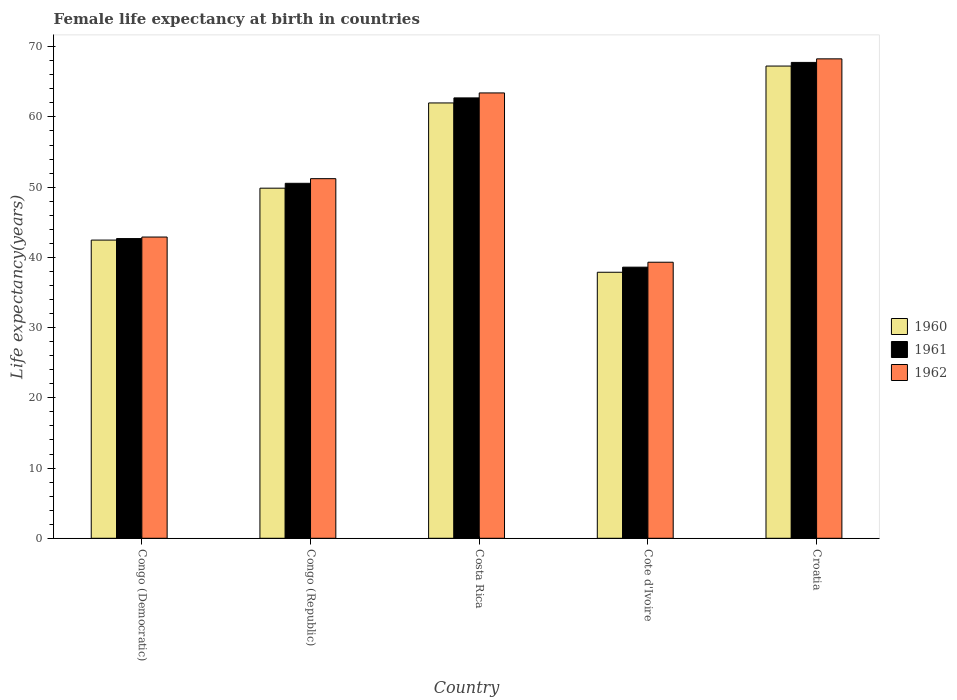Are the number of bars per tick equal to the number of legend labels?
Provide a short and direct response. Yes. Are the number of bars on each tick of the X-axis equal?
Ensure brevity in your answer.  Yes. How many bars are there on the 5th tick from the right?
Offer a very short reply. 3. What is the label of the 4th group of bars from the left?
Provide a succinct answer. Cote d'Ivoire. In how many cases, is the number of bars for a given country not equal to the number of legend labels?
Offer a terse response. 0. What is the female life expectancy at birth in 1962 in Congo (Democratic)?
Give a very brief answer. 42.9. Across all countries, what is the maximum female life expectancy at birth in 1961?
Provide a short and direct response. 67.77. Across all countries, what is the minimum female life expectancy at birth in 1961?
Make the answer very short. 38.61. In which country was the female life expectancy at birth in 1961 maximum?
Offer a terse response. Croatia. In which country was the female life expectancy at birth in 1960 minimum?
Offer a terse response. Cote d'Ivoire. What is the total female life expectancy at birth in 1960 in the graph?
Make the answer very short. 259.45. What is the difference between the female life expectancy at birth in 1960 in Congo (Democratic) and that in Cote d'Ivoire?
Provide a short and direct response. 4.58. What is the difference between the female life expectancy at birth in 1962 in Congo (Democratic) and the female life expectancy at birth in 1960 in Costa Rica?
Offer a very short reply. -19.1. What is the average female life expectancy at birth in 1960 per country?
Make the answer very short. 51.89. What is the difference between the female life expectancy at birth of/in 1960 and female life expectancy at birth of/in 1961 in Congo (Republic)?
Keep it short and to the point. -0.69. What is the ratio of the female life expectancy at birth in 1961 in Congo (Democratic) to that in Croatia?
Keep it short and to the point. 0.63. Is the difference between the female life expectancy at birth in 1960 in Cote d'Ivoire and Croatia greater than the difference between the female life expectancy at birth in 1961 in Cote d'Ivoire and Croatia?
Give a very brief answer. No. What is the difference between the highest and the second highest female life expectancy at birth in 1961?
Your answer should be compact. -17.22. What is the difference between the highest and the lowest female life expectancy at birth in 1962?
Keep it short and to the point. 28.96. What is the difference between two consecutive major ticks on the Y-axis?
Make the answer very short. 10. Are the values on the major ticks of Y-axis written in scientific E-notation?
Give a very brief answer. No. What is the title of the graph?
Your answer should be very brief. Female life expectancy at birth in countries. Does "2011" appear as one of the legend labels in the graph?
Provide a succinct answer. No. What is the label or title of the Y-axis?
Your answer should be compact. Life expectancy(years). What is the Life expectancy(years) of 1960 in Congo (Democratic)?
Offer a very short reply. 42.47. What is the Life expectancy(years) of 1961 in Congo (Democratic)?
Provide a short and direct response. 42.68. What is the Life expectancy(years) in 1962 in Congo (Democratic)?
Provide a short and direct response. 42.9. What is the Life expectancy(years) of 1960 in Congo (Republic)?
Make the answer very short. 49.86. What is the Life expectancy(years) in 1961 in Congo (Republic)?
Give a very brief answer. 50.55. What is the Life expectancy(years) of 1962 in Congo (Republic)?
Offer a terse response. 51.21. What is the Life expectancy(years) of 1960 in Costa Rica?
Provide a succinct answer. 62. What is the Life expectancy(years) of 1961 in Costa Rica?
Your answer should be compact. 62.71. What is the Life expectancy(years) of 1962 in Costa Rica?
Provide a succinct answer. 63.42. What is the Life expectancy(years) in 1960 in Cote d'Ivoire?
Your answer should be compact. 37.88. What is the Life expectancy(years) in 1961 in Cote d'Ivoire?
Keep it short and to the point. 38.61. What is the Life expectancy(years) in 1962 in Cote d'Ivoire?
Keep it short and to the point. 39.31. What is the Life expectancy(years) in 1960 in Croatia?
Make the answer very short. 67.25. What is the Life expectancy(years) of 1961 in Croatia?
Your answer should be compact. 67.77. What is the Life expectancy(years) of 1962 in Croatia?
Keep it short and to the point. 68.28. Across all countries, what is the maximum Life expectancy(years) in 1960?
Offer a very short reply. 67.25. Across all countries, what is the maximum Life expectancy(years) in 1961?
Your response must be concise. 67.77. Across all countries, what is the maximum Life expectancy(years) of 1962?
Offer a terse response. 68.28. Across all countries, what is the minimum Life expectancy(years) in 1960?
Offer a very short reply. 37.88. Across all countries, what is the minimum Life expectancy(years) of 1961?
Ensure brevity in your answer.  38.61. Across all countries, what is the minimum Life expectancy(years) of 1962?
Provide a short and direct response. 39.31. What is the total Life expectancy(years) in 1960 in the graph?
Offer a terse response. 259.45. What is the total Life expectancy(years) of 1961 in the graph?
Make the answer very short. 262.32. What is the total Life expectancy(years) in 1962 in the graph?
Your response must be concise. 265.12. What is the difference between the Life expectancy(years) of 1960 in Congo (Democratic) and that in Congo (Republic)?
Offer a very short reply. -7.39. What is the difference between the Life expectancy(years) of 1961 in Congo (Democratic) and that in Congo (Republic)?
Make the answer very short. -7.87. What is the difference between the Life expectancy(years) in 1962 in Congo (Democratic) and that in Congo (Republic)?
Your response must be concise. -8.31. What is the difference between the Life expectancy(years) in 1960 in Congo (Democratic) and that in Costa Rica?
Ensure brevity in your answer.  -19.53. What is the difference between the Life expectancy(years) of 1961 in Congo (Democratic) and that in Costa Rica?
Offer a very short reply. -20.03. What is the difference between the Life expectancy(years) of 1962 in Congo (Democratic) and that in Costa Rica?
Offer a very short reply. -20.52. What is the difference between the Life expectancy(years) in 1960 in Congo (Democratic) and that in Cote d'Ivoire?
Your answer should be compact. 4.58. What is the difference between the Life expectancy(years) of 1961 in Congo (Democratic) and that in Cote d'Ivoire?
Keep it short and to the point. 4.07. What is the difference between the Life expectancy(years) of 1962 in Congo (Democratic) and that in Cote d'Ivoire?
Give a very brief answer. 3.59. What is the difference between the Life expectancy(years) in 1960 in Congo (Democratic) and that in Croatia?
Offer a very short reply. -24.78. What is the difference between the Life expectancy(years) of 1961 in Congo (Democratic) and that in Croatia?
Ensure brevity in your answer.  -25.09. What is the difference between the Life expectancy(years) in 1962 in Congo (Democratic) and that in Croatia?
Make the answer very short. -25.38. What is the difference between the Life expectancy(years) of 1960 in Congo (Republic) and that in Costa Rica?
Offer a very short reply. -12.14. What is the difference between the Life expectancy(years) of 1961 in Congo (Republic) and that in Costa Rica?
Keep it short and to the point. -12.16. What is the difference between the Life expectancy(years) in 1962 in Congo (Republic) and that in Costa Rica?
Make the answer very short. -12.21. What is the difference between the Life expectancy(years) in 1960 in Congo (Republic) and that in Cote d'Ivoire?
Provide a short and direct response. 11.97. What is the difference between the Life expectancy(years) of 1961 in Congo (Republic) and that in Cote d'Ivoire?
Keep it short and to the point. 11.94. What is the difference between the Life expectancy(years) of 1962 in Congo (Republic) and that in Cote d'Ivoire?
Offer a very short reply. 11.9. What is the difference between the Life expectancy(years) of 1960 in Congo (Republic) and that in Croatia?
Offer a very short reply. -17.39. What is the difference between the Life expectancy(years) of 1961 in Congo (Republic) and that in Croatia?
Your response must be concise. -17.21. What is the difference between the Life expectancy(years) in 1962 in Congo (Republic) and that in Croatia?
Your answer should be compact. -17.06. What is the difference between the Life expectancy(years) of 1960 in Costa Rica and that in Cote d'Ivoire?
Give a very brief answer. 24.11. What is the difference between the Life expectancy(years) in 1961 in Costa Rica and that in Cote d'Ivoire?
Provide a short and direct response. 24.1. What is the difference between the Life expectancy(years) in 1962 in Costa Rica and that in Cote d'Ivoire?
Give a very brief answer. 24.11. What is the difference between the Life expectancy(years) of 1960 in Costa Rica and that in Croatia?
Provide a short and direct response. -5.25. What is the difference between the Life expectancy(years) of 1961 in Costa Rica and that in Croatia?
Give a very brief answer. -5.05. What is the difference between the Life expectancy(years) in 1962 in Costa Rica and that in Croatia?
Your answer should be compact. -4.85. What is the difference between the Life expectancy(years) in 1960 in Cote d'Ivoire and that in Croatia?
Provide a succinct answer. -29.36. What is the difference between the Life expectancy(years) in 1961 in Cote d'Ivoire and that in Croatia?
Your answer should be compact. -29.16. What is the difference between the Life expectancy(years) of 1962 in Cote d'Ivoire and that in Croatia?
Offer a very short reply. -28.96. What is the difference between the Life expectancy(years) in 1960 in Congo (Democratic) and the Life expectancy(years) in 1961 in Congo (Republic)?
Your answer should be compact. -8.09. What is the difference between the Life expectancy(years) of 1960 in Congo (Democratic) and the Life expectancy(years) of 1962 in Congo (Republic)?
Your answer should be compact. -8.75. What is the difference between the Life expectancy(years) of 1961 in Congo (Democratic) and the Life expectancy(years) of 1962 in Congo (Republic)?
Provide a short and direct response. -8.53. What is the difference between the Life expectancy(years) in 1960 in Congo (Democratic) and the Life expectancy(years) in 1961 in Costa Rica?
Offer a very short reply. -20.25. What is the difference between the Life expectancy(years) of 1960 in Congo (Democratic) and the Life expectancy(years) of 1962 in Costa Rica?
Your answer should be compact. -20.96. What is the difference between the Life expectancy(years) of 1961 in Congo (Democratic) and the Life expectancy(years) of 1962 in Costa Rica?
Offer a terse response. -20.74. What is the difference between the Life expectancy(years) in 1960 in Congo (Democratic) and the Life expectancy(years) in 1961 in Cote d'Ivoire?
Your answer should be compact. 3.85. What is the difference between the Life expectancy(years) of 1960 in Congo (Democratic) and the Life expectancy(years) of 1962 in Cote d'Ivoire?
Keep it short and to the point. 3.15. What is the difference between the Life expectancy(years) in 1961 in Congo (Democratic) and the Life expectancy(years) in 1962 in Cote d'Ivoire?
Offer a terse response. 3.37. What is the difference between the Life expectancy(years) in 1960 in Congo (Democratic) and the Life expectancy(years) in 1961 in Croatia?
Make the answer very short. -25.3. What is the difference between the Life expectancy(years) in 1960 in Congo (Democratic) and the Life expectancy(years) in 1962 in Croatia?
Keep it short and to the point. -25.81. What is the difference between the Life expectancy(years) in 1961 in Congo (Democratic) and the Life expectancy(years) in 1962 in Croatia?
Provide a succinct answer. -25.59. What is the difference between the Life expectancy(years) in 1960 in Congo (Republic) and the Life expectancy(years) in 1961 in Costa Rica?
Your answer should be very brief. -12.86. What is the difference between the Life expectancy(years) of 1960 in Congo (Republic) and the Life expectancy(years) of 1962 in Costa Rica?
Your answer should be compact. -13.56. What is the difference between the Life expectancy(years) in 1961 in Congo (Republic) and the Life expectancy(years) in 1962 in Costa Rica?
Make the answer very short. -12.87. What is the difference between the Life expectancy(years) of 1960 in Congo (Republic) and the Life expectancy(years) of 1961 in Cote d'Ivoire?
Provide a short and direct response. 11.25. What is the difference between the Life expectancy(years) of 1960 in Congo (Republic) and the Life expectancy(years) of 1962 in Cote d'Ivoire?
Make the answer very short. 10.54. What is the difference between the Life expectancy(years) in 1961 in Congo (Republic) and the Life expectancy(years) in 1962 in Cote d'Ivoire?
Your response must be concise. 11.24. What is the difference between the Life expectancy(years) in 1960 in Congo (Republic) and the Life expectancy(years) in 1961 in Croatia?
Give a very brief answer. -17.91. What is the difference between the Life expectancy(years) in 1960 in Congo (Republic) and the Life expectancy(years) in 1962 in Croatia?
Provide a succinct answer. -18.42. What is the difference between the Life expectancy(years) of 1961 in Congo (Republic) and the Life expectancy(years) of 1962 in Croatia?
Provide a succinct answer. -17.72. What is the difference between the Life expectancy(years) in 1960 in Costa Rica and the Life expectancy(years) in 1961 in Cote d'Ivoire?
Keep it short and to the point. 23.39. What is the difference between the Life expectancy(years) in 1960 in Costa Rica and the Life expectancy(years) in 1962 in Cote d'Ivoire?
Your response must be concise. 22.68. What is the difference between the Life expectancy(years) in 1961 in Costa Rica and the Life expectancy(years) in 1962 in Cote d'Ivoire?
Your answer should be very brief. 23.4. What is the difference between the Life expectancy(years) of 1960 in Costa Rica and the Life expectancy(years) of 1961 in Croatia?
Keep it short and to the point. -5.77. What is the difference between the Life expectancy(years) in 1960 in Costa Rica and the Life expectancy(years) in 1962 in Croatia?
Keep it short and to the point. -6.28. What is the difference between the Life expectancy(years) of 1961 in Costa Rica and the Life expectancy(years) of 1962 in Croatia?
Provide a short and direct response. -5.56. What is the difference between the Life expectancy(years) of 1960 in Cote d'Ivoire and the Life expectancy(years) of 1961 in Croatia?
Ensure brevity in your answer.  -29.88. What is the difference between the Life expectancy(years) in 1960 in Cote d'Ivoire and the Life expectancy(years) in 1962 in Croatia?
Your answer should be compact. -30.39. What is the difference between the Life expectancy(years) in 1961 in Cote d'Ivoire and the Life expectancy(years) in 1962 in Croatia?
Your response must be concise. -29.66. What is the average Life expectancy(years) of 1960 per country?
Provide a succinct answer. 51.89. What is the average Life expectancy(years) in 1961 per country?
Give a very brief answer. 52.46. What is the average Life expectancy(years) of 1962 per country?
Offer a very short reply. 53.02. What is the difference between the Life expectancy(years) of 1960 and Life expectancy(years) of 1961 in Congo (Democratic)?
Your answer should be compact. -0.22. What is the difference between the Life expectancy(years) in 1960 and Life expectancy(years) in 1962 in Congo (Democratic)?
Make the answer very short. -0.43. What is the difference between the Life expectancy(years) in 1961 and Life expectancy(years) in 1962 in Congo (Democratic)?
Keep it short and to the point. -0.22. What is the difference between the Life expectancy(years) in 1960 and Life expectancy(years) in 1961 in Congo (Republic)?
Ensure brevity in your answer.  -0.69. What is the difference between the Life expectancy(years) of 1960 and Life expectancy(years) of 1962 in Congo (Republic)?
Ensure brevity in your answer.  -1.35. What is the difference between the Life expectancy(years) of 1961 and Life expectancy(years) of 1962 in Congo (Republic)?
Ensure brevity in your answer.  -0.66. What is the difference between the Life expectancy(years) in 1960 and Life expectancy(years) in 1961 in Costa Rica?
Keep it short and to the point. -0.72. What is the difference between the Life expectancy(years) of 1960 and Life expectancy(years) of 1962 in Costa Rica?
Provide a short and direct response. -1.43. What is the difference between the Life expectancy(years) of 1961 and Life expectancy(years) of 1962 in Costa Rica?
Offer a terse response. -0.71. What is the difference between the Life expectancy(years) of 1960 and Life expectancy(years) of 1961 in Cote d'Ivoire?
Make the answer very short. -0.73. What is the difference between the Life expectancy(years) of 1960 and Life expectancy(years) of 1962 in Cote d'Ivoire?
Your answer should be compact. -1.43. What is the difference between the Life expectancy(years) of 1961 and Life expectancy(years) of 1962 in Cote d'Ivoire?
Offer a very short reply. -0.7. What is the difference between the Life expectancy(years) of 1960 and Life expectancy(years) of 1961 in Croatia?
Offer a very short reply. -0.52. What is the difference between the Life expectancy(years) of 1960 and Life expectancy(years) of 1962 in Croatia?
Give a very brief answer. -1.03. What is the difference between the Life expectancy(years) in 1961 and Life expectancy(years) in 1962 in Croatia?
Give a very brief answer. -0.51. What is the ratio of the Life expectancy(years) of 1960 in Congo (Democratic) to that in Congo (Republic)?
Your answer should be compact. 0.85. What is the ratio of the Life expectancy(years) of 1961 in Congo (Democratic) to that in Congo (Republic)?
Give a very brief answer. 0.84. What is the ratio of the Life expectancy(years) of 1962 in Congo (Democratic) to that in Congo (Republic)?
Provide a succinct answer. 0.84. What is the ratio of the Life expectancy(years) of 1960 in Congo (Democratic) to that in Costa Rica?
Offer a very short reply. 0.69. What is the ratio of the Life expectancy(years) of 1961 in Congo (Democratic) to that in Costa Rica?
Your answer should be compact. 0.68. What is the ratio of the Life expectancy(years) in 1962 in Congo (Democratic) to that in Costa Rica?
Provide a succinct answer. 0.68. What is the ratio of the Life expectancy(years) in 1960 in Congo (Democratic) to that in Cote d'Ivoire?
Offer a terse response. 1.12. What is the ratio of the Life expectancy(years) in 1961 in Congo (Democratic) to that in Cote d'Ivoire?
Offer a terse response. 1.11. What is the ratio of the Life expectancy(years) of 1962 in Congo (Democratic) to that in Cote d'Ivoire?
Your answer should be very brief. 1.09. What is the ratio of the Life expectancy(years) in 1960 in Congo (Democratic) to that in Croatia?
Offer a terse response. 0.63. What is the ratio of the Life expectancy(years) of 1961 in Congo (Democratic) to that in Croatia?
Make the answer very short. 0.63. What is the ratio of the Life expectancy(years) in 1962 in Congo (Democratic) to that in Croatia?
Give a very brief answer. 0.63. What is the ratio of the Life expectancy(years) in 1960 in Congo (Republic) to that in Costa Rica?
Provide a succinct answer. 0.8. What is the ratio of the Life expectancy(years) of 1961 in Congo (Republic) to that in Costa Rica?
Make the answer very short. 0.81. What is the ratio of the Life expectancy(years) of 1962 in Congo (Republic) to that in Costa Rica?
Your response must be concise. 0.81. What is the ratio of the Life expectancy(years) in 1960 in Congo (Republic) to that in Cote d'Ivoire?
Your response must be concise. 1.32. What is the ratio of the Life expectancy(years) of 1961 in Congo (Republic) to that in Cote d'Ivoire?
Provide a short and direct response. 1.31. What is the ratio of the Life expectancy(years) of 1962 in Congo (Republic) to that in Cote d'Ivoire?
Provide a succinct answer. 1.3. What is the ratio of the Life expectancy(years) in 1960 in Congo (Republic) to that in Croatia?
Offer a very short reply. 0.74. What is the ratio of the Life expectancy(years) in 1961 in Congo (Republic) to that in Croatia?
Give a very brief answer. 0.75. What is the ratio of the Life expectancy(years) of 1962 in Congo (Republic) to that in Croatia?
Make the answer very short. 0.75. What is the ratio of the Life expectancy(years) of 1960 in Costa Rica to that in Cote d'Ivoire?
Keep it short and to the point. 1.64. What is the ratio of the Life expectancy(years) in 1961 in Costa Rica to that in Cote d'Ivoire?
Ensure brevity in your answer.  1.62. What is the ratio of the Life expectancy(years) in 1962 in Costa Rica to that in Cote d'Ivoire?
Offer a terse response. 1.61. What is the ratio of the Life expectancy(years) in 1960 in Costa Rica to that in Croatia?
Keep it short and to the point. 0.92. What is the ratio of the Life expectancy(years) of 1961 in Costa Rica to that in Croatia?
Your answer should be compact. 0.93. What is the ratio of the Life expectancy(years) of 1962 in Costa Rica to that in Croatia?
Your response must be concise. 0.93. What is the ratio of the Life expectancy(years) in 1960 in Cote d'Ivoire to that in Croatia?
Give a very brief answer. 0.56. What is the ratio of the Life expectancy(years) in 1961 in Cote d'Ivoire to that in Croatia?
Ensure brevity in your answer.  0.57. What is the ratio of the Life expectancy(years) of 1962 in Cote d'Ivoire to that in Croatia?
Offer a very short reply. 0.58. What is the difference between the highest and the second highest Life expectancy(years) of 1960?
Make the answer very short. 5.25. What is the difference between the highest and the second highest Life expectancy(years) of 1961?
Offer a very short reply. 5.05. What is the difference between the highest and the second highest Life expectancy(years) of 1962?
Your response must be concise. 4.85. What is the difference between the highest and the lowest Life expectancy(years) of 1960?
Provide a short and direct response. 29.36. What is the difference between the highest and the lowest Life expectancy(years) in 1961?
Your answer should be compact. 29.16. What is the difference between the highest and the lowest Life expectancy(years) of 1962?
Give a very brief answer. 28.96. 